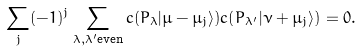Convert formula to latex. <formula><loc_0><loc_0><loc_500><loc_500>\sum _ { j } ( - 1 ) ^ { j } \sum _ { \lambda , \lambda ^ { \prime } \text {even} } c ( P _ { \lambda } | \mu - \mu _ { j } \rangle ) c ( P _ { \lambda ^ { \prime } } | \nu + \mu _ { j } \rangle ) = 0 .</formula> 